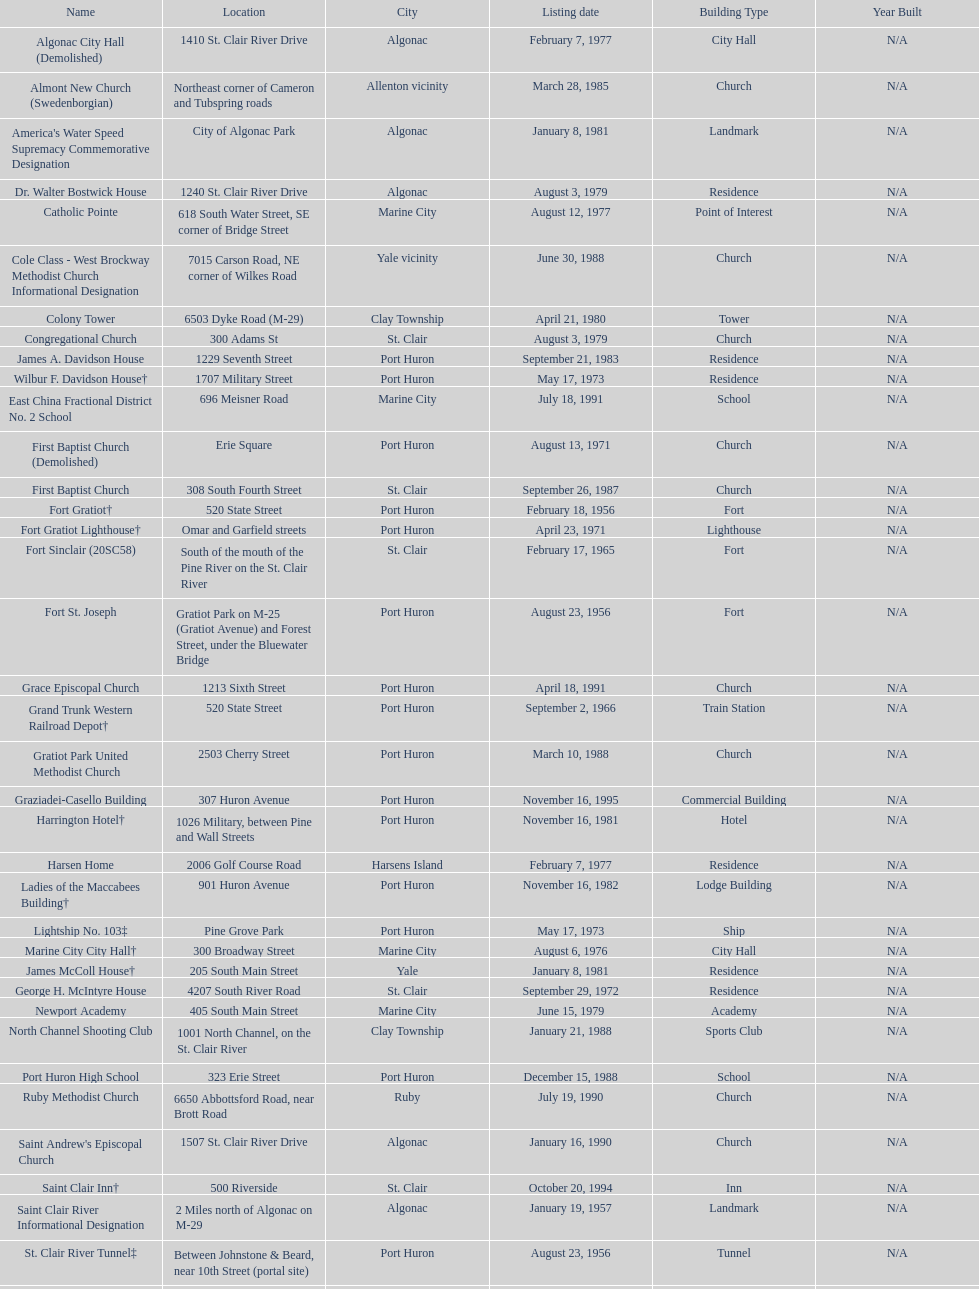What is the number of properties on the list that have been demolished? 2. 